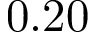<formula> <loc_0><loc_0><loc_500><loc_500>0 . 2 0</formula> 